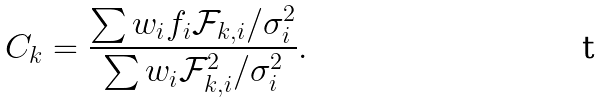<formula> <loc_0><loc_0><loc_500><loc_500>C _ { k } = \frac { \sum w _ { i } f _ { i } \mathcal { F } _ { k , i } / \sigma _ { i } ^ { 2 } } { \sum w _ { i } \mathcal { F } _ { k , i } ^ { 2 } / \sigma _ { i } ^ { 2 } } .</formula> 